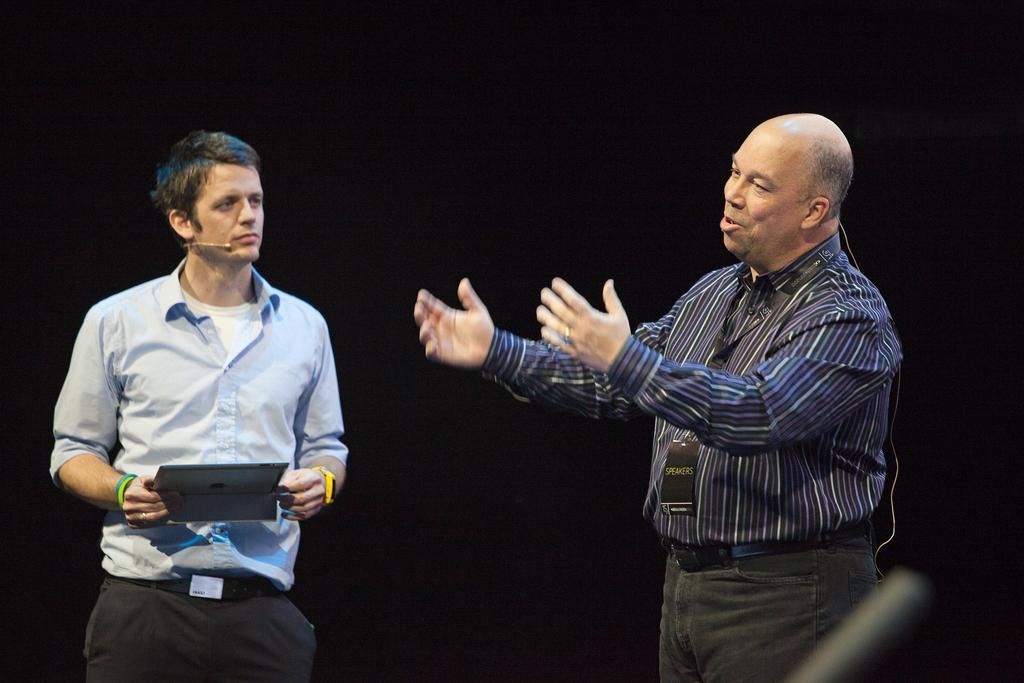In one or two sentences, can you explain what this image depicts? In the picture I can see a person standing in the right corner and there is a wire behind him and there is another person standing beside him is holding a tab in his hands in the left corner. 